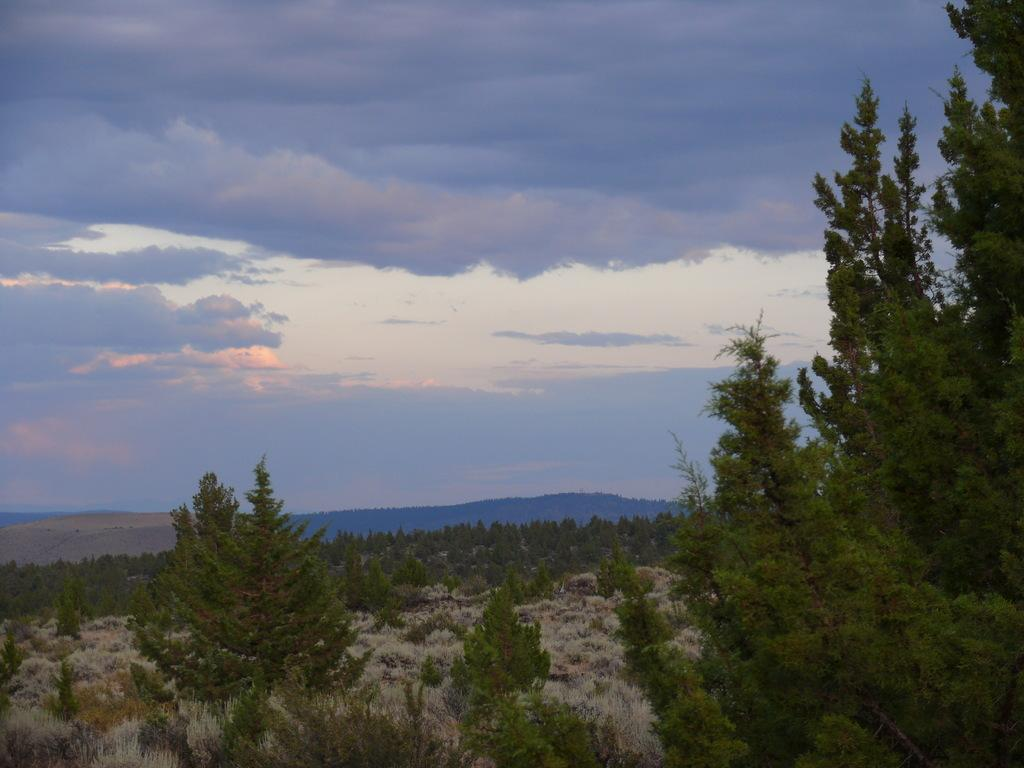What type of natural environment is depicted in the image? The image features many trees and mountains in the background. What can be seen in the sky in the image? The sky is visible in the background of the image, along with clouds. How many types of natural features are present in the image? There are at least three types of natural features present: trees, mountains, and the sky. What type of stew is being prepared in the image? There is no stew present in the image; it features a natural environment with trees, mountains, and the sky. What degree of difficulty is associated with climbing the mountains in the image? The image does not provide information about the difficulty of climbing the mountains, nor does it show any people attempting to climb them. 